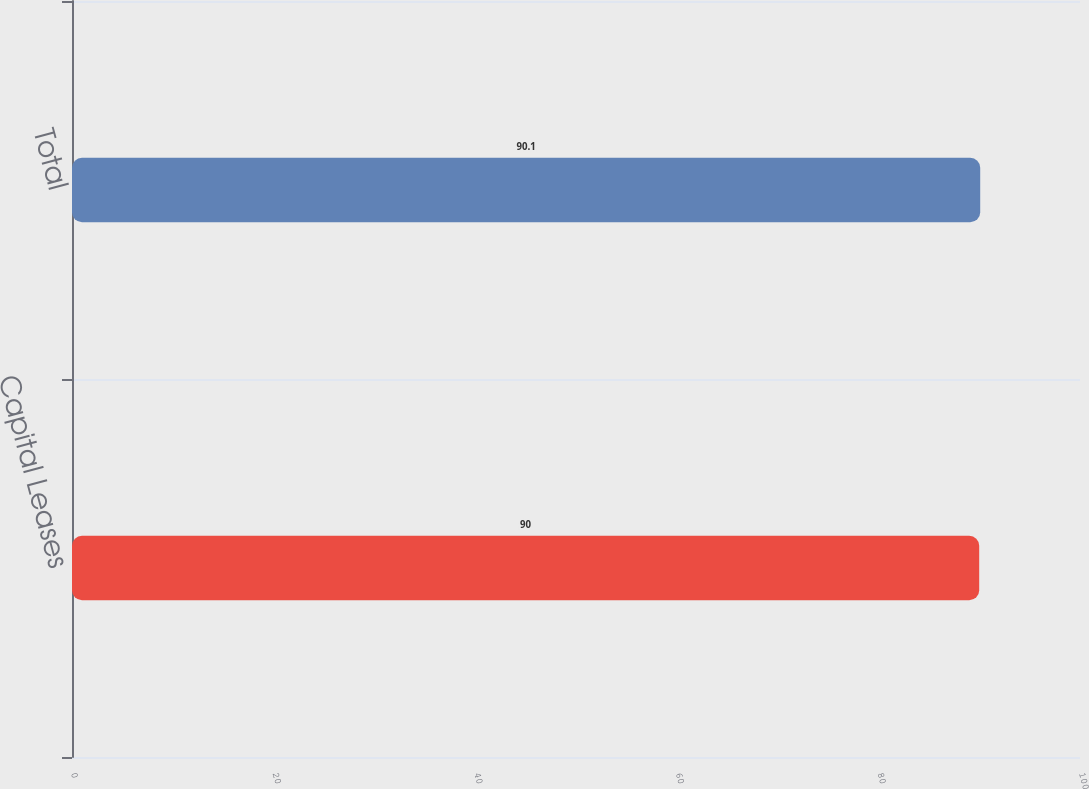Convert chart to OTSL. <chart><loc_0><loc_0><loc_500><loc_500><bar_chart><fcel>Capital Leases<fcel>Total<nl><fcel>90<fcel>90.1<nl></chart> 